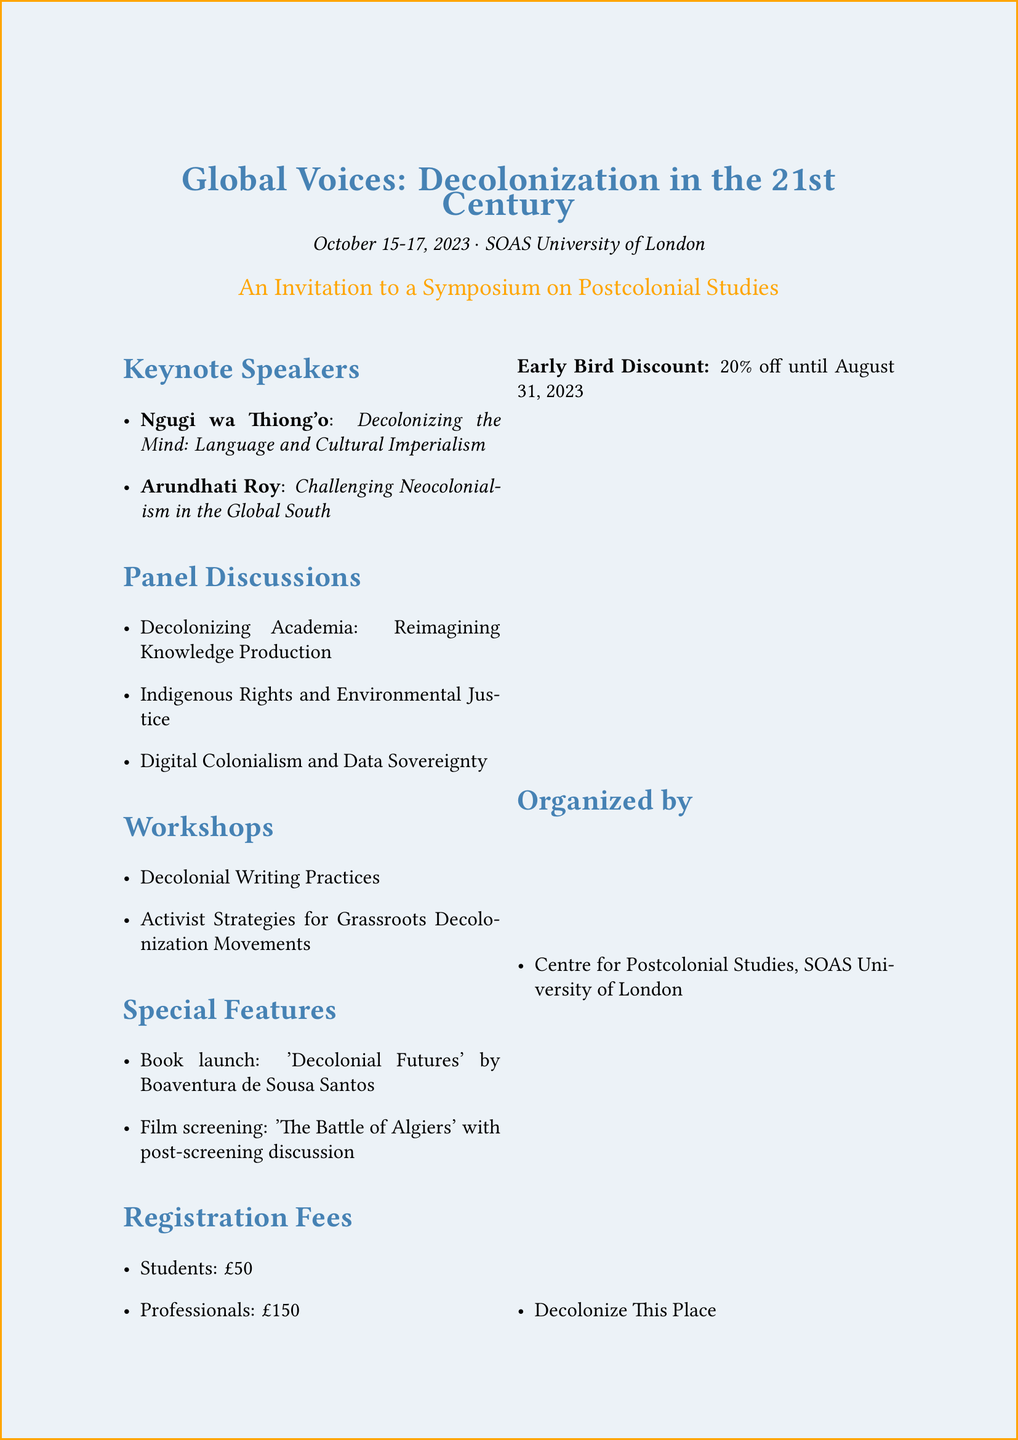What are the dates of the symposium? The dates of the symposium are explicitly stated in the document as October 15-17, 2023.
Answer: October 15-17, 2023 Who is one of the keynote speakers? The document lists prominent keynote speakers, including Ngugi wa Thiong'o and Arundhati Roy.
Answer: Ngugi wa Thiong'o What is the registration fee for professionals? The document specifies that the registration fee for professionals is £150.
Answer: £150 What is one panel discussion topic? The document lists various panel discussions, one of which is "Decolonizing Academia: Reimagining Knowledge Production."
Answer: Decolonizing Academia: Reimagining Knowledge Production What is the early bird discount percentage? The document states that there is a 20% off early bird discount available until August 31, 2023.
Answer: 20% Which organization is one of the event organizers? The document mentions the Centre for Postcolonial Studies, SOAS University of London as an organizer.
Answer: Centre for Postcolonial Studies, SOAS University of London What special feature includes a book launch? The document specifies a book launch as a special feature, highlighting 'Decolonial Futures' by Boaventura de Sousa Santos.
Answer: Book launch: 'Decolonial Futures' What is the email for contact? The document provides a contact email for inquiries regarding the symposium.
Answer: decolonization.symposium@soas.ac.uk 